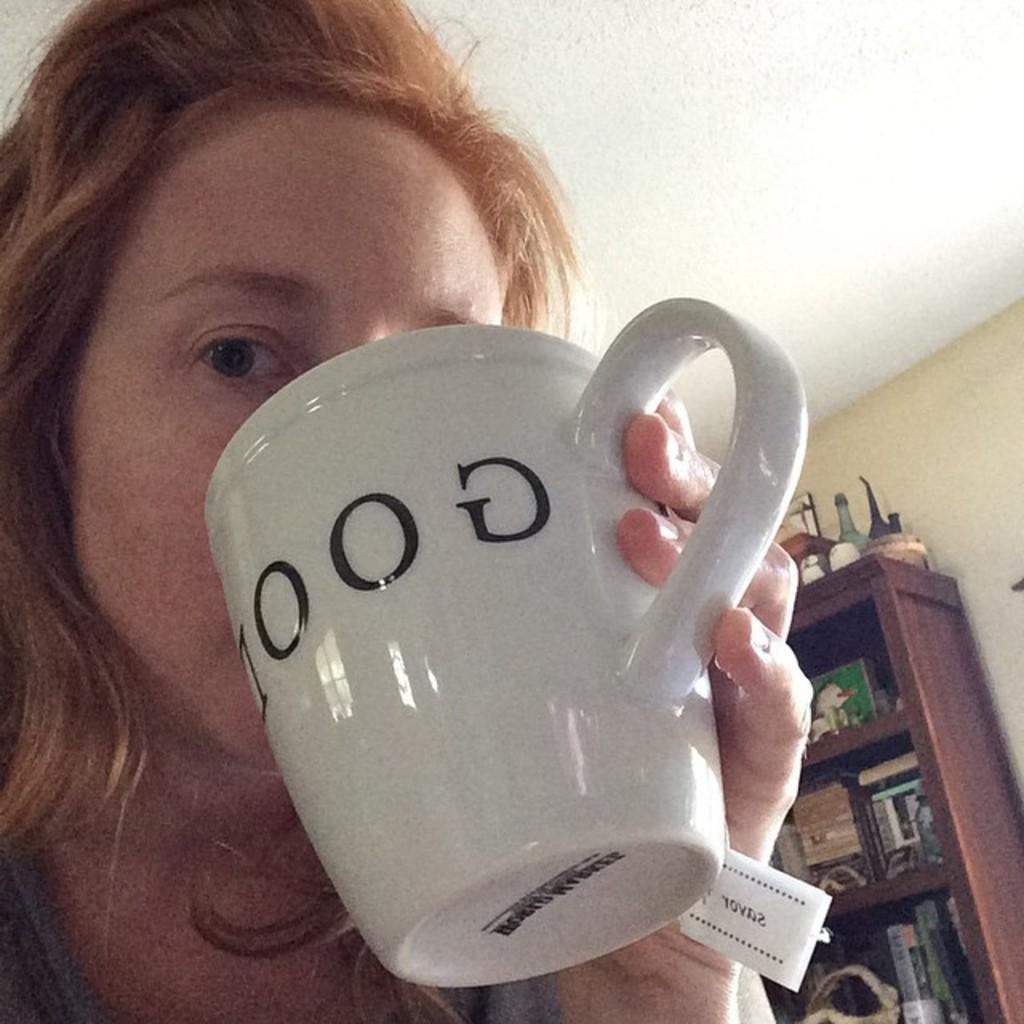Can you describe this image briefly? There is a woman holding coffee cup and behind her there is a shelf and things in it. 